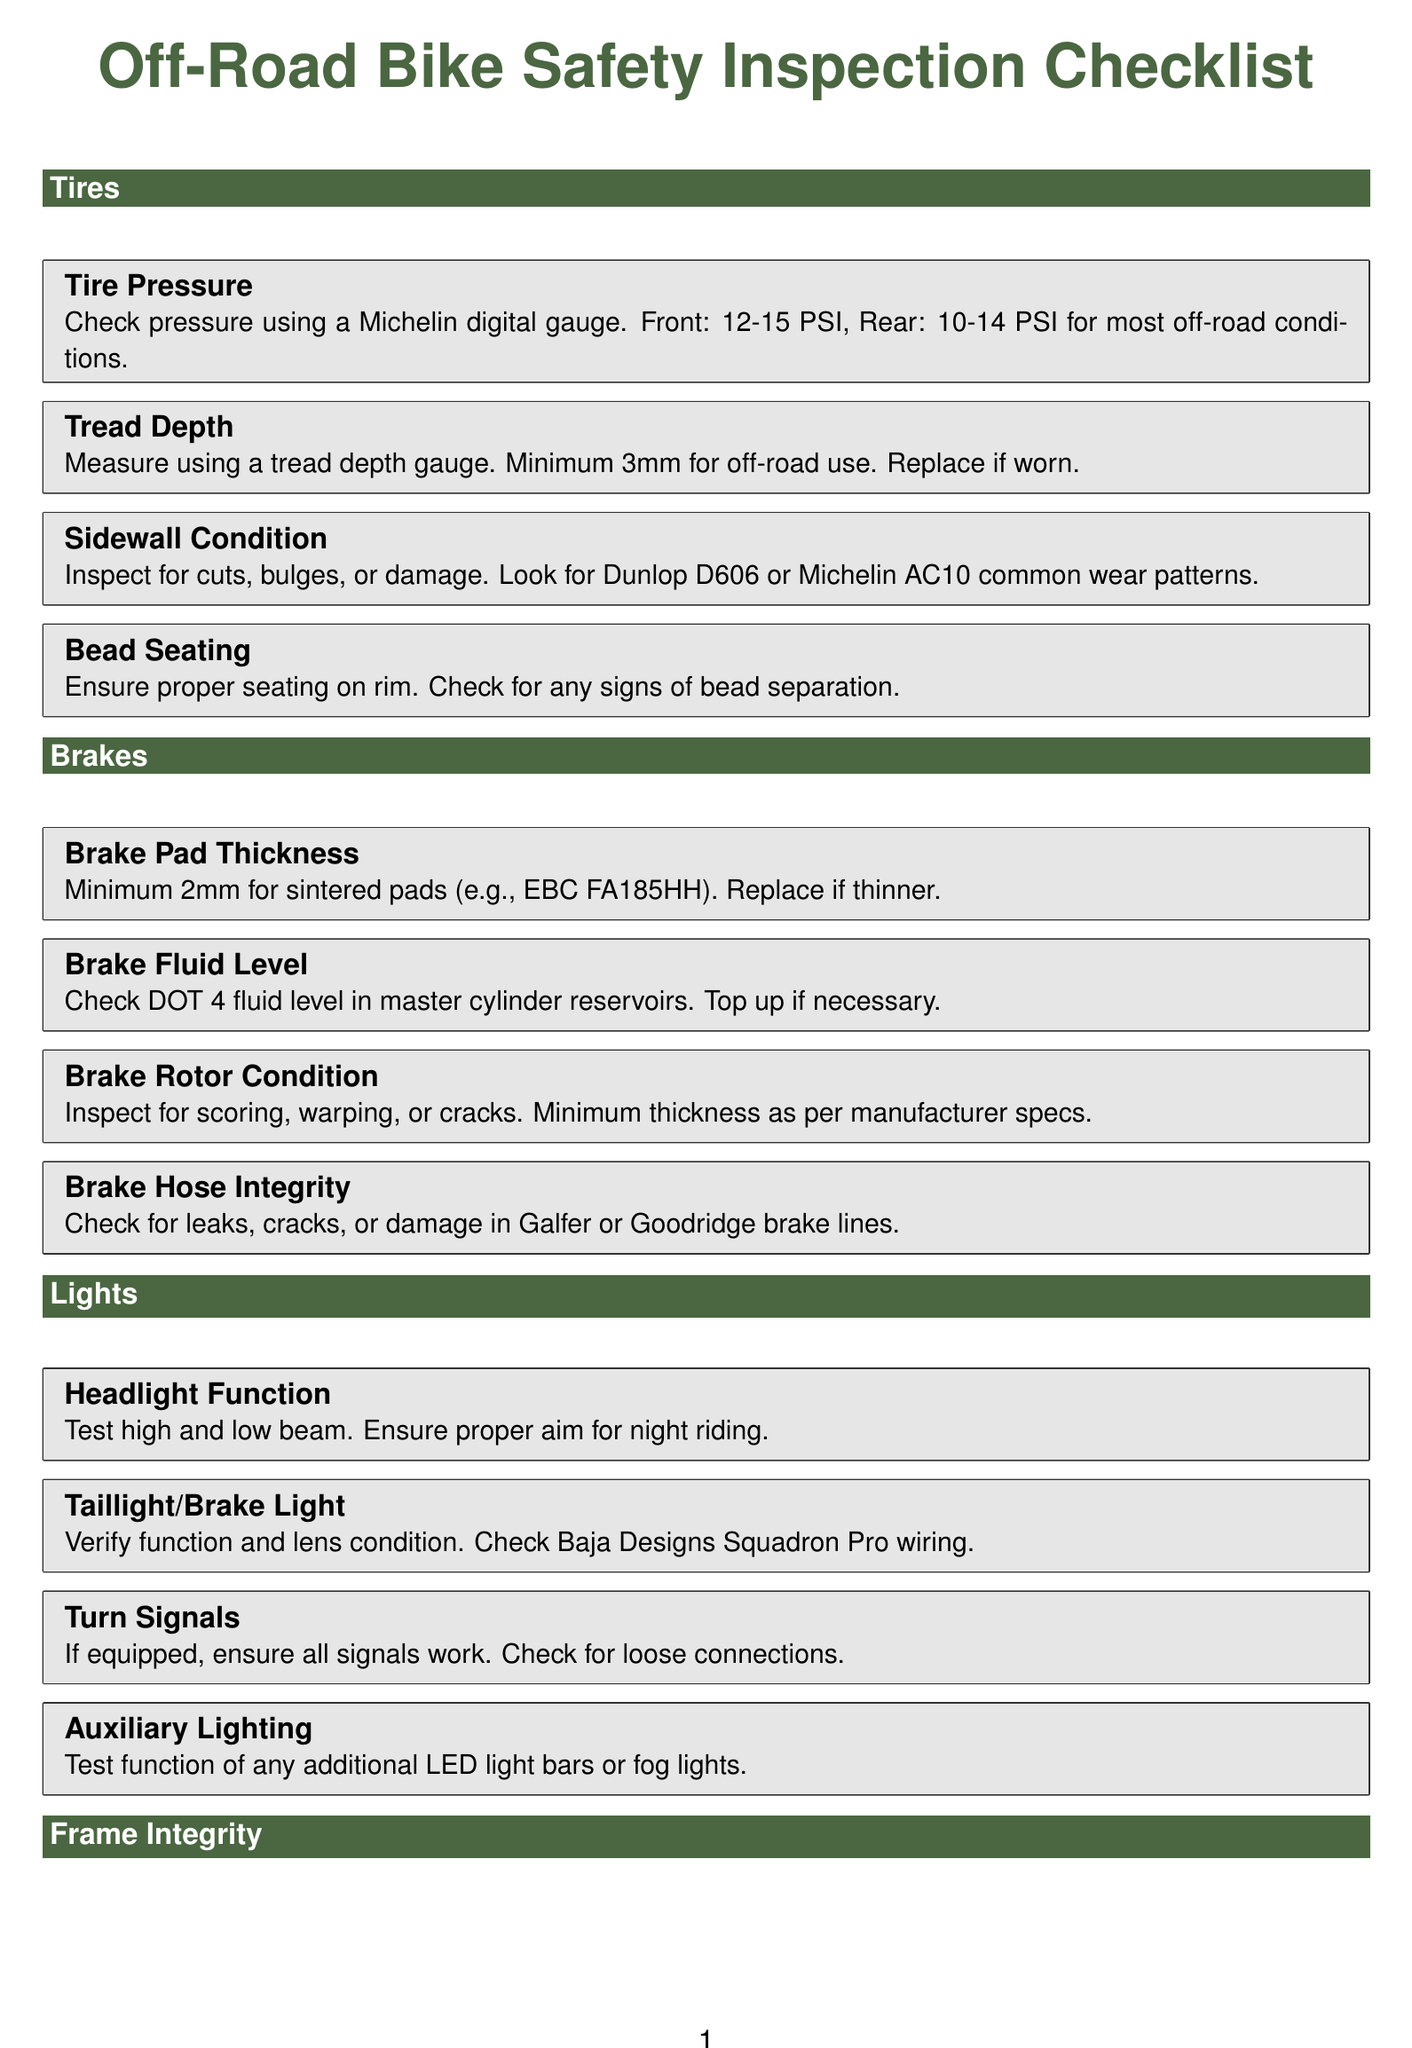What is the minimum tire pressure for the front tire? The document specifies that the front tire pressure should be between 12-15 PSI for most off-road conditions.
Answer: 12-15 PSI What should the tread depth be at a minimum for off-road use? According to the document, the minimum tread depth should be 3mm for off-road use.
Answer: 3mm What is the minimum brake pad thickness specified in the document? The document states that the minimum brake pad thickness for sintered pads should be 2mm.
Answer: 2mm What type of brake fluid should be checked in the master cylinder? The document mentions that DOT 4 fluid should be checked in the master cylinder reservoirs.
Answer: DOT 4 What should be inspected for cuts, bulges, or damage on the tires? The document indicates that the sidewall condition should be inspected for cuts, bulges, or damage.
Answer: Sidewall condition Why should the skid plate be inspected? The document specifies that the skid plate needs to be inspected for damage and to ensure proper attachment.
Answer: Damage and attachment What is one of the auxiliary lighting components mentioned for testing? The auxiliary lighting section references testing additional LED light bars or fog lights.
Answer: LED light bars Which part of the bike should be checked for oil leaks in forks? The document states that suspension should be checked for oil leaks in forks and shock.
Answer: Suspension What is the purpose of checking brake hose integrity? The document indicates that brake hose integrity should be checked to look for leaks, cracks, or damage.
Answer: Leaks, cracks, or damage 